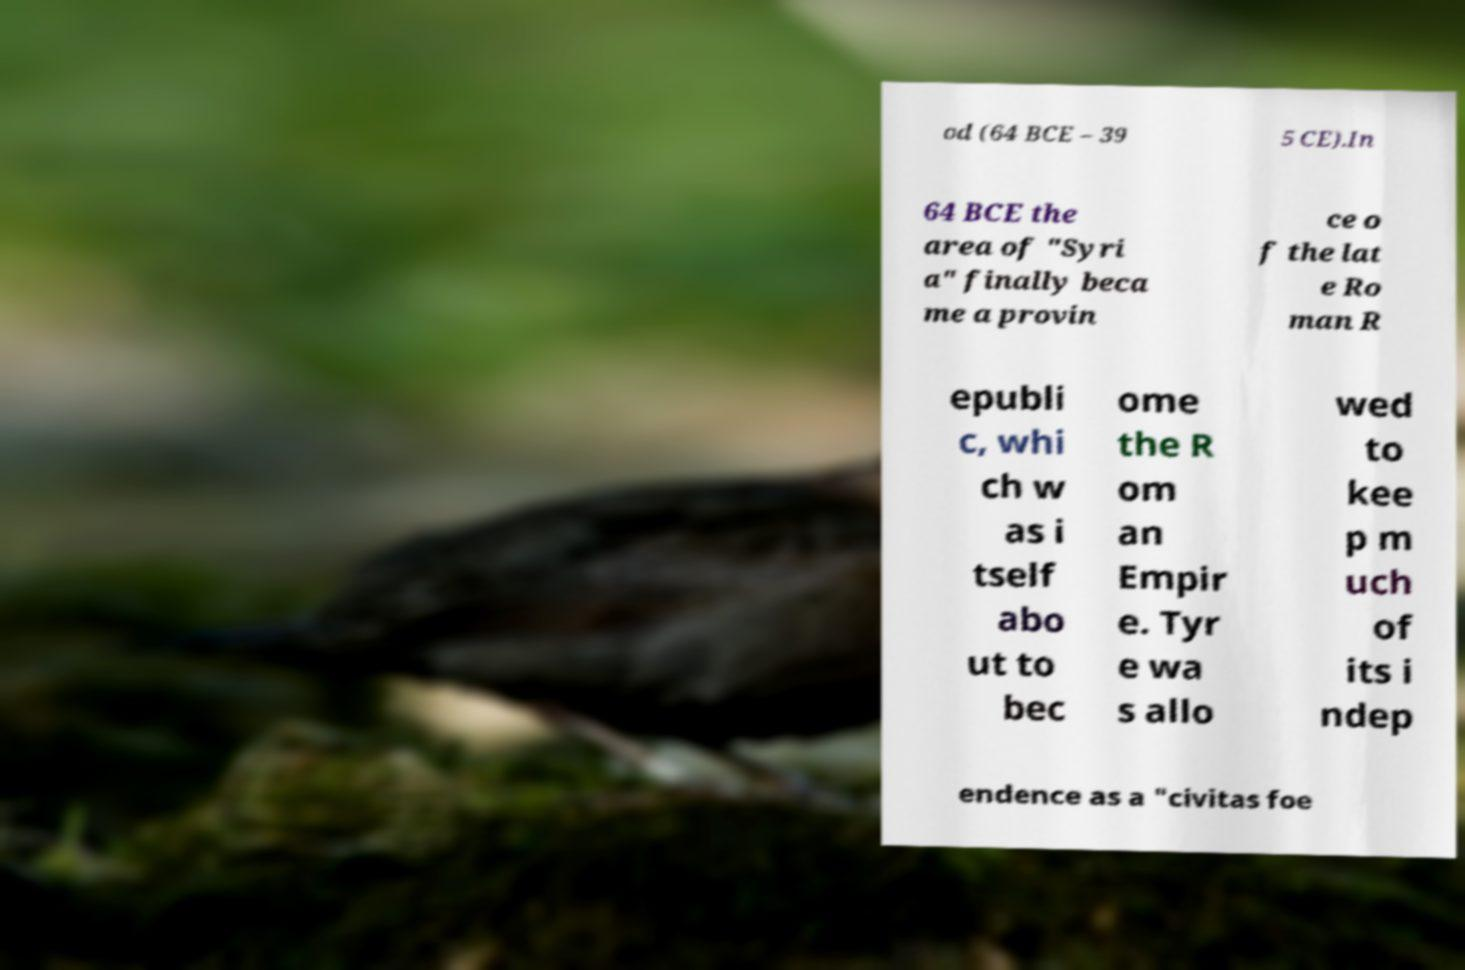There's text embedded in this image that I need extracted. Can you transcribe it verbatim? od (64 BCE – 39 5 CE).In 64 BCE the area of "Syri a" finally beca me a provin ce o f the lat e Ro man R epubli c, whi ch w as i tself abo ut to bec ome the R om an Empir e. Tyr e wa s allo wed to kee p m uch of its i ndep endence as a "civitas foe 